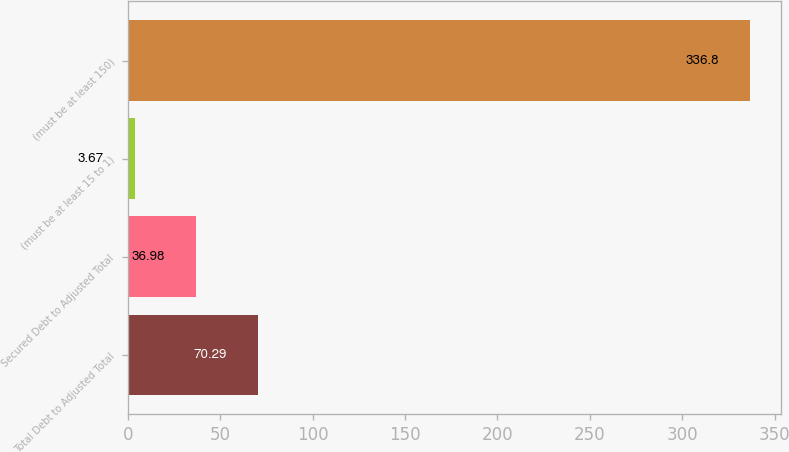Convert chart to OTSL. <chart><loc_0><loc_0><loc_500><loc_500><bar_chart><fcel>Total Debt to Adjusted Total<fcel>Secured Debt to Adjusted Total<fcel>(must be at least 15 to 1)<fcel>(must be at least 150)<nl><fcel>70.29<fcel>36.98<fcel>3.67<fcel>336.8<nl></chart> 